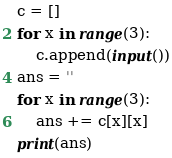<code> <loc_0><loc_0><loc_500><loc_500><_Python_>c = []
for x in range(3):
    c.append(input())
ans = ''
for x in range(3):
    ans += c[x][x]
print(ans)
</code> 